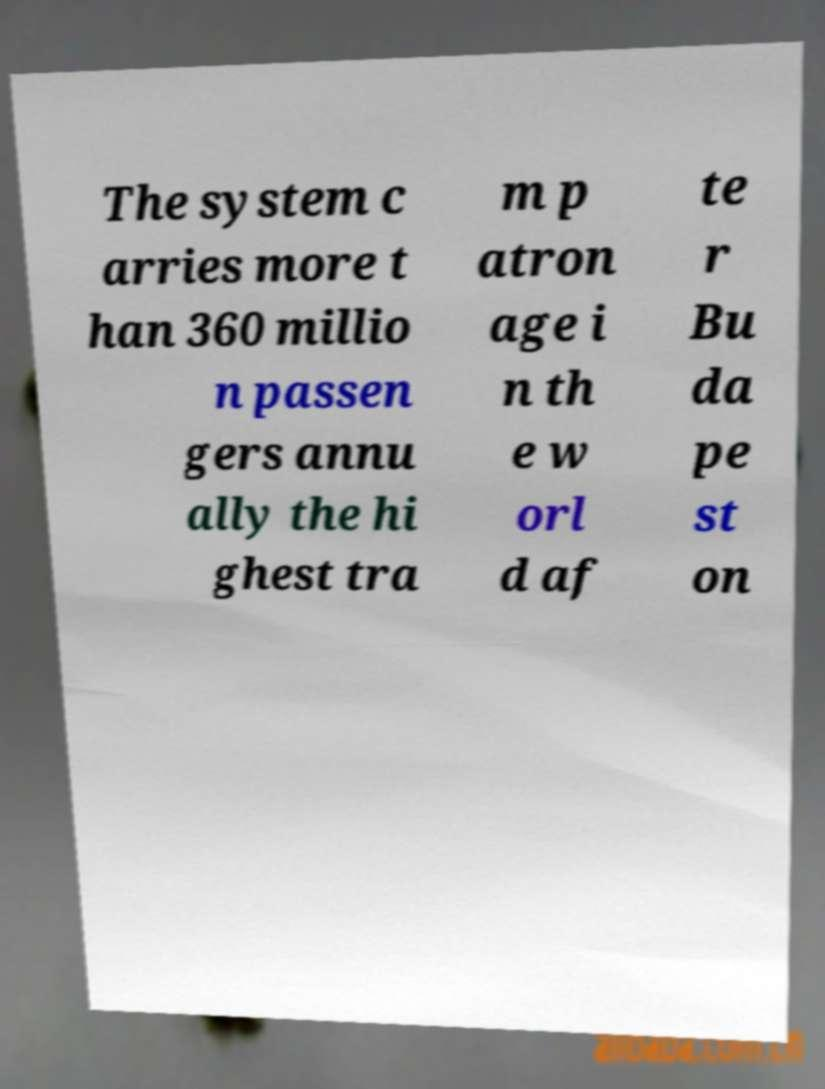There's text embedded in this image that I need extracted. Can you transcribe it verbatim? The system c arries more t han 360 millio n passen gers annu ally the hi ghest tra m p atron age i n th e w orl d af te r Bu da pe st on 